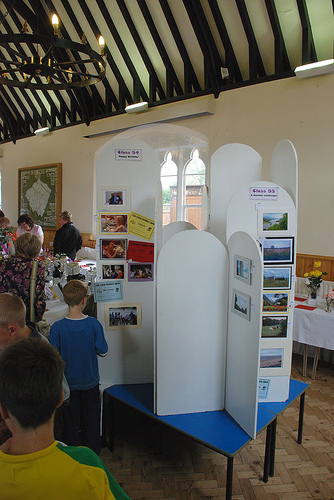<image>
Is the boy behind the table? No. The boy is not behind the table. From this viewpoint, the boy appears to be positioned elsewhere in the scene. Is the boy under the roof? Yes. The boy is positioned underneath the roof, with the roof above it in the vertical space. 